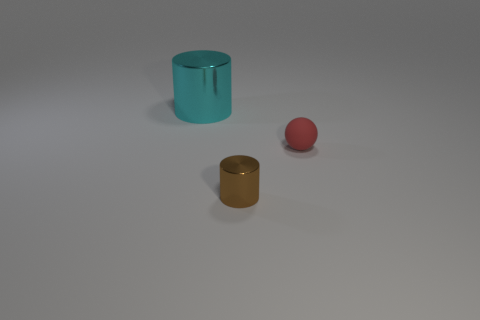There is a brown metallic thing that is the same size as the sphere; what shape is it?
Provide a short and direct response. Cylinder. Is there a cylinder of the same color as the small rubber thing?
Your response must be concise. No. Does the small rubber object have the same shape as the small brown metal thing?
Make the answer very short. No. How many tiny objects are cyan cylinders or rubber things?
Your response must be concise. 1. There is a small object that is made of the same material as the cyan cylinder; what is its color?
Give a very brief answer. Brown. How many other cylinders are made of the same material as the brown cylinder?
Keep it short and to the point. 1. There is a cylinder in front of the large metallic thing; does it have the same size as the metallic object behind the tiny rubber sphere?
Your response must be concise. No. The thing in front of the tiny object that is right of the brown object is made of what material?
Your response must be concise. Metal. Are there fewer small cylinders that are in front of the tiny shiny cylinder than things that are right of the large cylinder?
Give a very brief answer. Yes. Are there any other things that are the same shape as the cyan metallic object?
Keep it short and to the point. Yes. 